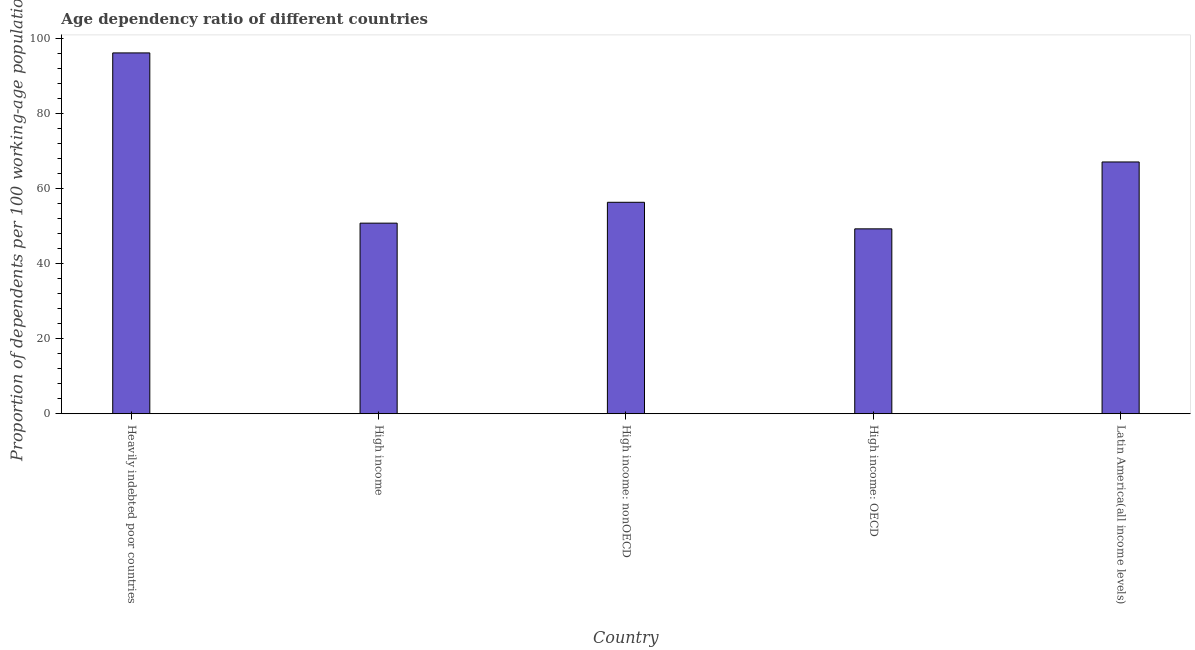Does the graph contain any zero values?
Your response must be concise. No. Does the graph contain grids?
Your answer should be very brief. No. What is the title of the graph?
Provide a short and direct response. Age dependency ratio of different countries. What is the label or title of the X-axis?
Ensure brevity in your answer.  Country. What is the label or title of the Y-axis?
Provide a short and direct response. Proportion of dependents per 100 working-age population. What is the age dependency ratio in High income: nonOECD?
Give a very brief answer. 56.35. Across all countries, what is the maximum age dependency ratio?
Offer a terse response. 96.16. Across all countries, what is the minimum age dependency ratio?
Offer a terse response. 49.27. In which country was the age dependency ratio maximum?
Ensure brevity in your answer.  Heavily indebted poor countries. In which country was the age dependency ratio minimum?
Keep it short and to the point. High income: OECD. What is the sum of the age dependency ratio?
Your answer should be very brief. 319.68. What is the difference between the age dependency ratio in High income: OECD and High income: nonOECD?
Provide a succinct answer. -7.08. What is the average age dependency ratio per country?
Ensure brevity in your answer.  63.94. What is the median age dependency ratio?
Offer a terse response. 56.35. What is the ratio of the age dependency ratio in High income: nonOECD to that in Latin America(all income levels)?
Provide a short and direct response. 0.84. Is the difference between the age dependency ratio in Heavily indebted poor countries and High income: nonOECD greater than the difference between any two countries?
Your answer should be compact. No. What is the difference between the highest and the second highest age dependency ratio?
Your answer should be compact. 29.06. Is the sum of the age dependency ratio in High income and Latin America(all income levels) greater than the maximum age dependency ratio across all countries?
Your response must be concise. Yes. What is the difference between the highest and the lowest age dependency ratio?
Your answer should be very brief. 46.89. In how many countries, is the age dependency ratio greater than the average age dependency ratio taken over all countries?
Provide a short and direct response. 2. Are all the bars in the graph horizontal?
Your answer should be compact. No. What is the Proportion of dependents per 100 working-age population of Heavily indebted poor countries?
Keep it short and to the point. 96.16. What is the Proportion of dependents per 100 working-age population in High income?
Ensure brevity in your answer.  50.79. What is the Proportion of dependents per 100 working-age population of High income: nonOECD?
Make the answer very short. 56.35. What is the Proportion of dependents per 100 working-age population in High income: OECD?
Provide a succinct answer. 49.27. What is the Proportion of dependents per 100 working-age population of Latin America(all income levels)?
Keep it short and to the point. 67.1. What is the difference between the Proportion of dependents per 100 working-age population in Heavily indebted poor countries and High income?
Provide a succinct answer. 45.37. What is the difference between the Proportion of dependents per 100 working-age population in Heavily indebted poor countries and High income: nonOECD?
Give a very brief answer. 39.81. What is the difference between the Proportion of dependents per 100 working-age population in Heavily indebted poor countries and High income: OECD?
Ensure brevity in your answer.  46.89. What is the difference between the Proportion of dependents per 100 working-age population in Heavily indebted poor countries and Latin America(all income levels)?
Your answer should be compact. 29.06. What is the difference between the Proportion of dependents per 100 working-age population in High income and High income: nonOECD?
Offer a terse response. -5.56. What is the difference between the Proportion of dependents per 100 working-age population in High income and High income: OECD?
Provide a short and direct response. 1.52. What is the difference between the Proportion of dependents per 100 working-age population in High income and Latin America(all income levels)?
Provide a short and direct response. -16.3. What is the difference between the Proportion of dependents per 100 working-age population in High income: nonOECD and High income: OECD?
Ensure brevity in your answer.  7.08. What is the difference between the Proportion of dependents per 100 working-age population in High income: nonOECD and Latin America(all income levels)?
Ensure brevity in your answer.  -10.74. What is the difference between the Proportion of dependents per 100 working-age population in High income: OECD and Latin America(all income levels)?
Provide a short and direct response. -17.82. What is the ratio of the Proportion of dependents per 100 working-age population in Heavily indebted poor countries to that in High income?
Give a very brief answer. 1.89. What is the ratio of the Proportion of dependents per 100 working-age population in Heavily indebted poor countries to that in High income: nonOECD?
Give a very brief answer. 1.71. What is the ratio of the Proportion of dependents per 100 working-age population in Heavily indebted poor countries to that in High income: OECD?
Provide a succinct answer. 1.95. What is the ratio of the Proportion of dependents per 100 working-age population in Heavily indebted poor countries to that in Latin America(all income levels)?
Provide a short and direct response. 1.43. What is the ratio of the Proportion of dependents per 100 working-age population in High income to that in High income: nonOECD?
Make the answer very short. 0.9. What is the ratio of the Proportion of dependents per 100 working-age population in High income to that in High income: OECD?
Your response must be concise. 1.03. What is the ratio of the Proportion of dependents per 100 working-age population in High income to that in Latin America(all income levels)?
Offer a very short reply. 0.76. What is the ratio of the Proportion of dependents per 100 working-age population in High income: nonOECD to that in High income: OECD?
Make the answer very short. 1.14. What is the ratio of the Proportion of dependents per 100 working-age population in High income: nonOECD to that in Latin America(all income levels)?
Ensure brevity in your answer.  0.84. What is the ratio of the Proportion of dependents per 100 working-age population in High income: OECD to that in Latin America(all income levels)?
Your answer should be compact. 0.73. 